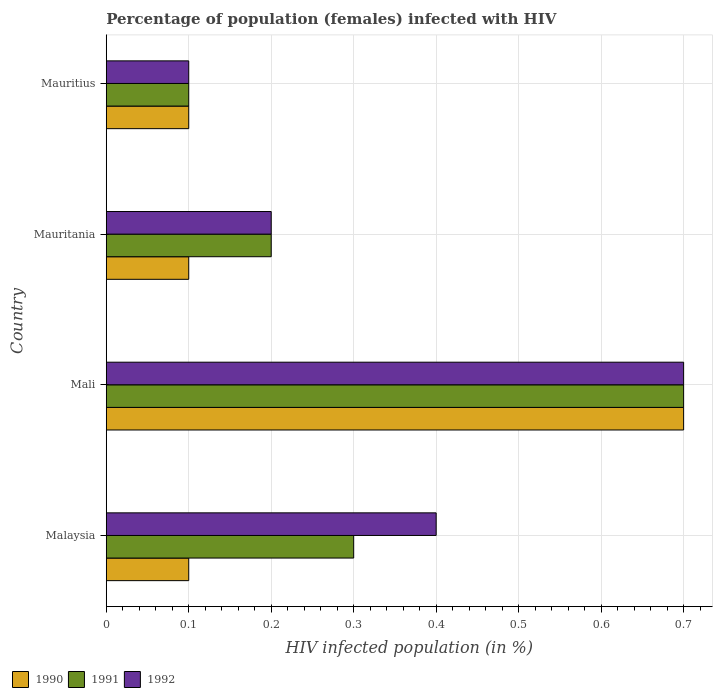Are the number of bars per tick equal to the number of legend labels?
Make the answer very short. Yes. How many bars are there on the 1st tick from the top?
Keep it short and to the point. 3. What is the label of the 4th group of bars from the top?
Give a very brief answer. Malaysia. What is the percentage of HIV infected female population in 1991 in Mauritania?
Provide a short and direct response. 0.2. Across all countries, what is the maximum percentage of HIV infected female population in 1990?
Your answer should be very brief. 0.7. Across all countries, what is the minimum percentage of HIV infected female population in 1991?
Offer a terse response. 0.1. In which country was the percentage of HIV infected female population in 1992 maximum?
Keep it short and to the point. Mali. In which country was the percentage of HIV infected female population in 1990 minimum?
Your answer should be very brief. Malaysia. What is the total percentage of HIV infected female population in 1990 in the graph?
Make the answer very short. 1. What is the difference between the percentage of HIV infected female population in 1990 in Mali and that in Mauritius?
Provide a succinct answer. 0.6. What is the difference between the percentage of HIV infected female population in 1992 in Mauritius and the percentage of HIV infected female population in 1991 in Mali?
Make the answer very short. -0.6. What is the average percentage of HIV infected female population in 1992 per country?
Provide a short and direct response. 0.35. What is the difference between the percentage of HIV infected female population in 1990 and percentage of HIV infected female population in 1992 in Mauritania?
Give a very brief answer. -0.1. In how many countries, is the percentage of HIV infected female population in 1992 greater than 0.52 %?
Give a very brief answer. 1. What is the ratio of the percentage of HIV infected female population in 1992 in Malaysia to that in Mali?
Provide a succinct answer. 0.57. Is the percentage of HIV infected female population in 1990 in Mali less than that in Mauritius?
Your answer should be very brief. No. What is the difference between the highest and the second highest percentage of HIV infected female population in 1991?
Offer a very short reply. 0.4. What is the difference between the highest and the lowest percentage of HIV infected female population in 1992?
Your response must be concise. 0.6. What does the 1st bar from the bottom in Mali represents?
Give a very brief answer. 1990. How many bars are there?
Offer a very short reply. 12. Are all the bars in the graph horizontal?
Provide a short and direct response. Yes. How many countries are there in the graph?
Keep it short and to the point. 4. Does the graph contain grids?
Give a very brief answer. Yes. How many legend labels are there?
Offer a terse response. 3. How are the legend labels stacked?
Your response must be concise. Horizontal. What is the title of the graph?
Ensure brevity in your answer.  Percentage of population (females) infected with HIV. What is the label or title of the X-axis?
Make the answer very short. HIV infected population (in %). What is the HIV infected population (in %) of 1991 in Mali?
Offer a very short reply. 0.7. What is the HIV infected population (in %) of 1991 in Mauritania?
Offer a very short reply. 0.2. Across all countries, what is the maximum HIV infected population (in %) of 1991?
Provide a succinct answer. 0.7. Across all countries, what is the maximum HIV infected population (in %) of 1992?
Provide a succinct answer. 0.7. Across all countries, what is the minimum HIV infected population (in %) of 1990?
Your answer should be very brief. 0.1. What is the total HIV infected population (in %) in 1990 in the graph?
Your response must be concise. 1. What is the total HIV infected population (in %) of 1991 in the graph?
Provide a succinct answer. 1.3. What is the total HIV infected population (in %) of 1992 in the graph?
Provide a short and direct response. 1.4. What is the difference between the HIV infected population (in %) of 1990 in Malaysia and that in Mali?
Offer a terse response. -0.6. What is the difference between the HIV infected population (in %) of 1991 in Malaysia and that in Mali?
Keep it short and to the point. -0.4. What is the difference between the HIV infected population (in %) of 1990 in Malaysia and that in Mauritania?
Offer a terse response. 0. What is the difference between the HIV infected population (in %) in 1990 in Malaysia and that in Mauritius?
Make the answer very short. 0. What is the difference between the HIV infected population (in %) of 1992 in Malaysia and that in Mauritius?
Keep it short and to the point. 0.3. What is the difference between the HIV infected population (in %) in 1990 in Mali and that in Mauritius?
Provide a succinct answer. 0.6. What is the difference between the HIV infected population (in %) in 1991 in Mali and that in Mauritius?
Ensure brevity in your answer.  0.6. What is the difference between the HIV infected population (in %) in 1992 in Mali and that in Mauritius?
Keep it short and to the point. 0.6. What is the difference between the HIV infected population (in %) in 1990 in Mauritania and that in Mauritius?
Offer a terse response. 0. What is the difference between the HIV infected population (in %) in 1990 in Malaysia and the HIV infected population (in %) in 1991 in Mali?
Give a very brief answer. -0.6. What is the difference between the HIV infected population (in %) of 1990 in Malaysia and the HIV infected population (in %) of 1992 in Mali?
Make the answer very short. -0.6. What is the difference between the HIV infected population (in %) of 1991 in Malaysia and the HIV infected population (in %) of 1992 in Mali?
Keep it short and to the point. -0.4. What is the difference between the HIV infected population (in %) of 1990 in Mali and the HIV infected population (in %) of 1991 in Mauritania?
Your response must be concise. 0.5. What is the difference between the HIV infected population (in %) of 1991 in Mali and the HIV infected population (in %) of 1992 in Mauritius?
Your answer should be very brief. 0.6. What is the difference between the HIV infected population (in %) of 1990 in Mauritania and the HIV infected population (in %) of 1991 in Mauritius?
Provide a short and direct response. 0. What is the difference between the HIV infected population (in %) of 1990 in Mauritania and the HIV infected population (in %) of 1992 in Mauritius?
Provide a short and direct response. 0. What is the average HIV infected population (in %) of 1990 per country?
Offer a very short reply. 0.25. What is the average HIV infected population (in %) in 1991 per country?
Offer a very short reply. 0.33. What is the average HIV infected population (in %) of 1992 per country?
Ensure brevity in your answer.  0.35. What is the difference between the HIV infected population (in %) of 1990 and HIV infected population (in %) of 1991 in Mali?
Provide a short and direct response. 0. What is the difference between the HIV infected population (in %) in 1990 and HIV infected population (in %) in 1992 in Mali?
Provide a succinct answer. 0. What is the difference between the HIV infected population (in %) of 1991 and HIV infected population (in %) of 1992 in Mali?
Your response must be concise. 0. What is the difference between the HIV infected population (in %) of 1990 and HIV infected population (in %) of 1991 in Mauritania?
Give a very brief answer. -0.1. What is the difference between the HIV infected population (in %) in 1991 and HIV infected population (in %) in 1992 in Mauritania?
Offer a very short reply. 0. What is the difference between the HIV infected population (in %) of 1990 and HIV infected population (in %) of 1992 in Mauritius?
Your response must be concise. 0. What is the difference between the HIV infected population (in %) of 1991 and HIV infected population (in %) of 1992 in Mauritius?
Provide a short and direct response. 0. What is the ratio of the HIV infected population (in %) of 1990 in Malaysia to that in Mali?
Give a very brief answer. 0.14. What is the ratio of the HIV infected population (in %) in 1991 in Malaysia to that in Mali?
Provide a short and direct response. 0.43. What is the ratio of the HIV infected population (in %) in 1992 in Malaysia to that in Mali?
Keep it short and to the point. 0.57. What is the ratio of the HIV infected population (in %) of 1991 in Malaysia to that in Mauritius?
Provide a succinct answer. 3. What is the ratio of the HIV infected population (in %) of 1992 in Mali to that in Mauritania?
Give a very brief answer. 3.5. What is the ratio of the HIV infected population (in %) of 1992 in Mali to that in Mauritius?
Your response must be concise. 7. What is the ratio of the HIV infected population (in %) in 1990 in Mauritania to that in Mauritius?
Provide a short and direct response. 1. What is the difference between the highest and the second highest HIV infected population (in %) of 1990?
Your answer should be compact. 0.6. What is the difference between the highest and the second highest HIV infected population (in %) in 1992?
Make the answer very short. 0.3. What is the difference between the highest and the lowest HIV infected population (in %) in 1991?
Offer a very short reply. 0.6. 